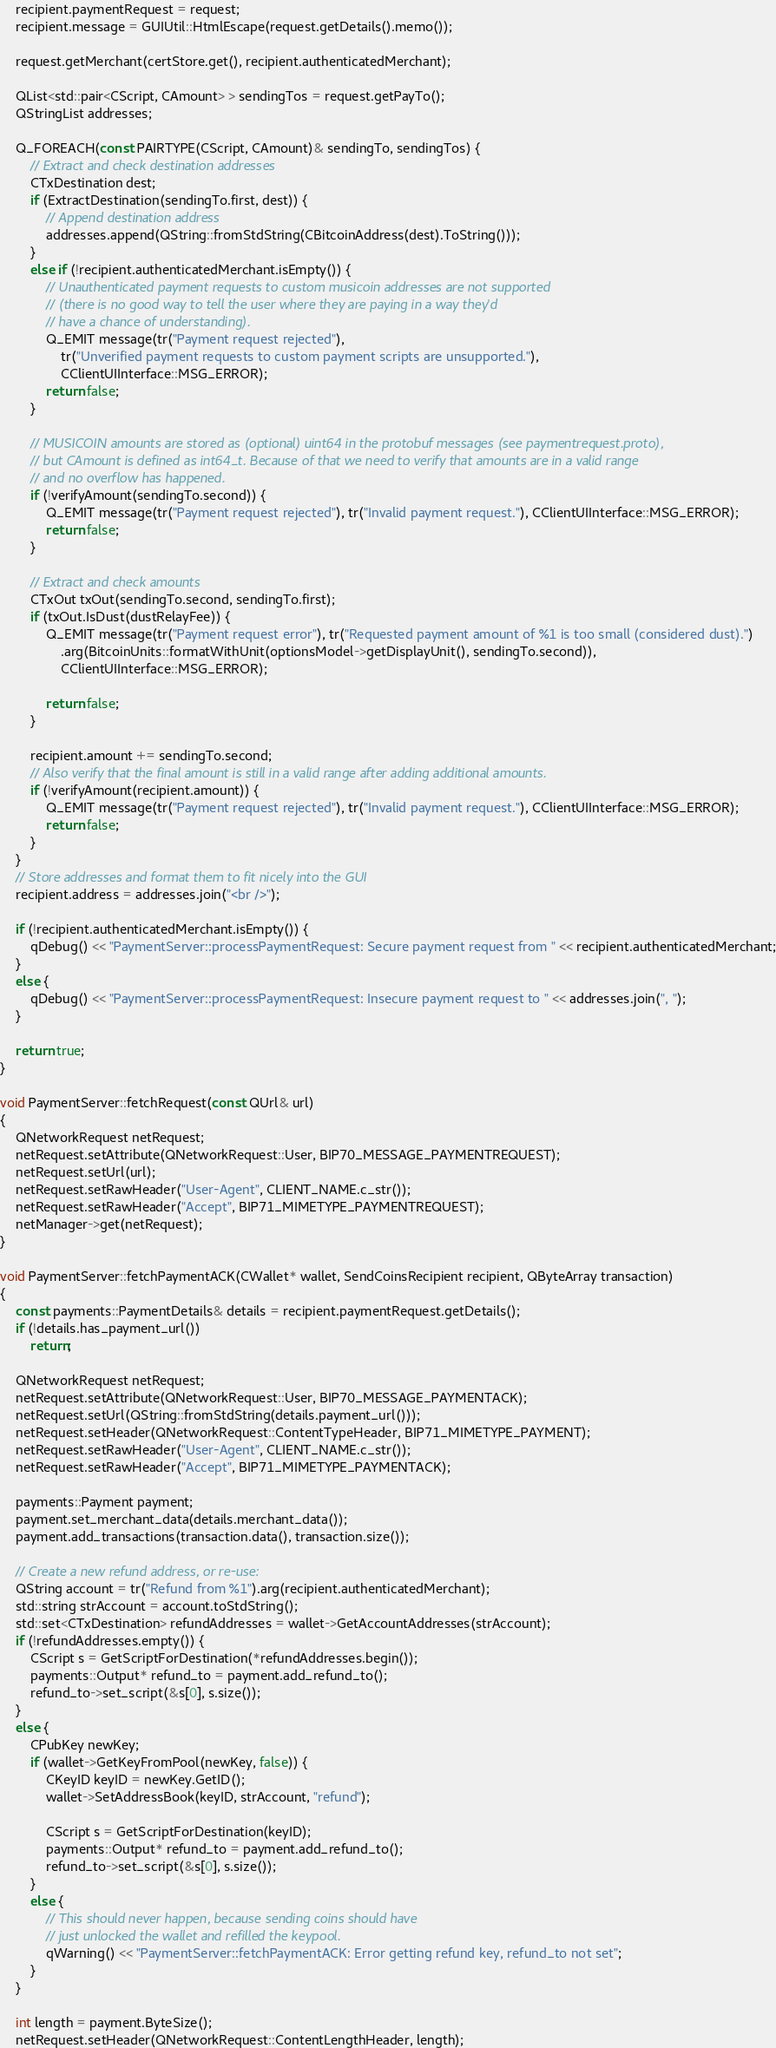<code> <loc_0><loc_0><loc_500><loc_500><_C++_>    recipient.paymentRequest = request;
    recipient.message = GUIUtil::HtmlEscape(request.getDetails().memo());

    request.getMerchant(certStore.get(), recipient.authenticatedMerchant);

    QList<std::pair<CScript, CAmount> > sendingTos = request.getPayTo();
    QStringList addresses;

    Q_FOREACH(const PAIRTYPE(CScript, CAmount)& sendingTo, sendingTos) {
        // Extract and check destination addresses
        CTxDestination dest;
        if (ExtractDestination(sendingTo.first, dest)) {
            // Append destination address
            addresses.append(QString::fromStdString(CBitcoinAddress(dest).ToString()));
        }
        else if (!recipient.authenticatedMerchant.isEmpty()) {
            // Unauthenticated payment requests to custom musicoin addresses are not supported
            // (there is no good way to tell the user where they are paying in a way they'd
            // have a chance of understanding).
            Q_EMIT message(tr("Payment request rejected"),
                tr("Unverified payment requests to custom payment scripts are unsupported."),
                CClientUIInterface::MSG_ERROR);
            return false;
        }

        // MUSICOIN amounts are stored as (optional) uint64 in the protobuf messages (see paymentrequest.proto),
        // but CAmount is defined as int64_t. Because of that we need to verify that amounts are in a valid range
        // and no overflow has happened.
        if (!verifyAmount(sendingTo.second)) {
            Q_EMIT message(tr("Payment request rejected"), tr("Invalid payment request."), CClientUIInterface::MSG_ERROR);
            return false;
        }

        // Extract and check amounts
        CTxOut txOut(sendingTo.second, sendingTo.first);
        if (txOut.IsDust(dustRelayFee)) {
            Q_EMIT message(tr("Payment request error"), tr("Requested payment amount of %1 is too small (considered dust).")
                .arg(BitcoinUnits::formatWithUnit(optionsModel->getDisplayUnit(), sendingTo.second)),
                CClientUIInterface::MSG_ERROR);

            return false;
        }

        recipient.amount += sendingTo.second;
        // Also verify that the final amount is still in a valid range after adding additional amounts.
        if (!verifyAmount(recipient.amount)) {
            Q_EMIT message(tr("Payment request rejected"), tr("Invalid payment request."), CClientUIInterface::MSG_ERROR);
            return false;
        }
    }
    // Store addresses and format them to fit nicely into the GUI
    recipient.address = addresses.join("<br />");

    if (!recipient.authenticatedMerchant.isEmpty()) {
        qDebug() << "PaymentServer::processPaymentRequest: Secure payment request from " << recipient.authenticatedMerchant;
    }
    else {
        qDebug() << "PaymentServer::processPaymentRequest: Insecure payment request to " << addresses.join(", ");
    }

    return true;
}

void PaymentServer::fetchRequest(const QUrl& url)
{
    QNetworkRequest netRequest;
    netRequest.setAttribute(QNetworkRequest::User, BIP70_MESSAGE_PAYMENTREQUEST);
    netRequest.setUrl(url);
    netRequest.setRawHeader("User-Agent", CLIENT_NAME.c_str());
    netRequest.setRawHeader("Accept", BIP71_MIMETYPE_PAYMENTREQUEST);
    netManager->get(netRequest);
}

void PaymentServer::fetchPaymentACK(CWallet* wallet, SendCoinsRecipient recipient, QByteArray transaction)
{
    const payments::PaymentDetails& details = recipient.paymentRequest.getDetails();
    if (!details.has_payment_url())
        return;

    QNetworkRequest netRequest;
    netRequest.setAttribute(QNetworkRequest::User, BIP70_MESSAGE_PAYMENTACK);
    netRequest.setUrl(QString::fromStdString(details.payment_url()));
    netRequest.setHeader(QNetworkRequest::ContentTypeHeader, BIP71_MIMETYPE_PAYMENT);
    netRequest.setRawHeader("User-Agent", CLIENT_NAME.c_str());
    netRequest.setRawHeader("Accept", BIP71_MIMETYPE_PAYMENTACK);

    payments::Payment payment;
    payment.set_merchant_data(details.merchant_data());
    payment.add_transactions(transaction.data(), transaction.size());

    // Create a new refund address, or re-use:
    QString account = tr("Refund from %1").arg(recipient.authenticatedMerchant);
    std::string strAccount = account.toStdString();
    std::set<CTxDestination> refundAddresses = wallet->GetAccountAddresses(strAccount);
    if (!refundAddresses.empty()) {
        CScript s = GetScriptForDestination(*refundAddresses.begin());
        payments::Output* refund_to = payment.add_refund_to();
        refund_to->set_script(&s[0], s.size());
    }
    else {
        CPubKey newKey;
        if (wallet->GetKeyFromPool(newKey, false)) {
            CKeyID keyID = newKey.GetID();
            wallet->SetAddressBook(keyID, strAccount, "refund");

            CScript s = GetScriptForDestination(keyID);
            payments::Output* refund_to = payment.add_refund_to();
            refund_to->set_script(&s[0], s.size());
        }
        else {
            // This should never happen, because sending coins should have
            // just unlocked the wallet and refilled the keypool.
            qWarning() << "PaymentServer::fetchPaymentACK: Error getting refund key, refund_to not set";
        }
    }

    int length = payment.ByteSize();
    netRequest.setHeader(QNetworkRequest::ContentLengthHeader, length);</code> 